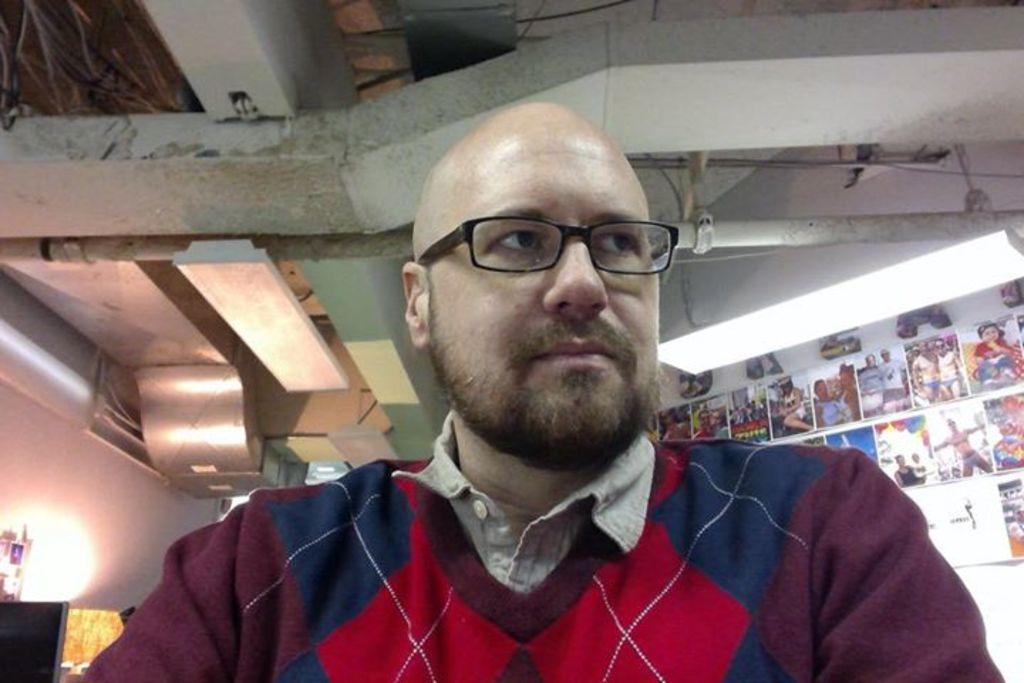How would you summarize this image in a sentence or two? At the bottom of this image, there is a person wearing a spectacle and watching something. In the background, there are lights attached to a roof, there are posters attached to a white wall and there are other objects. 